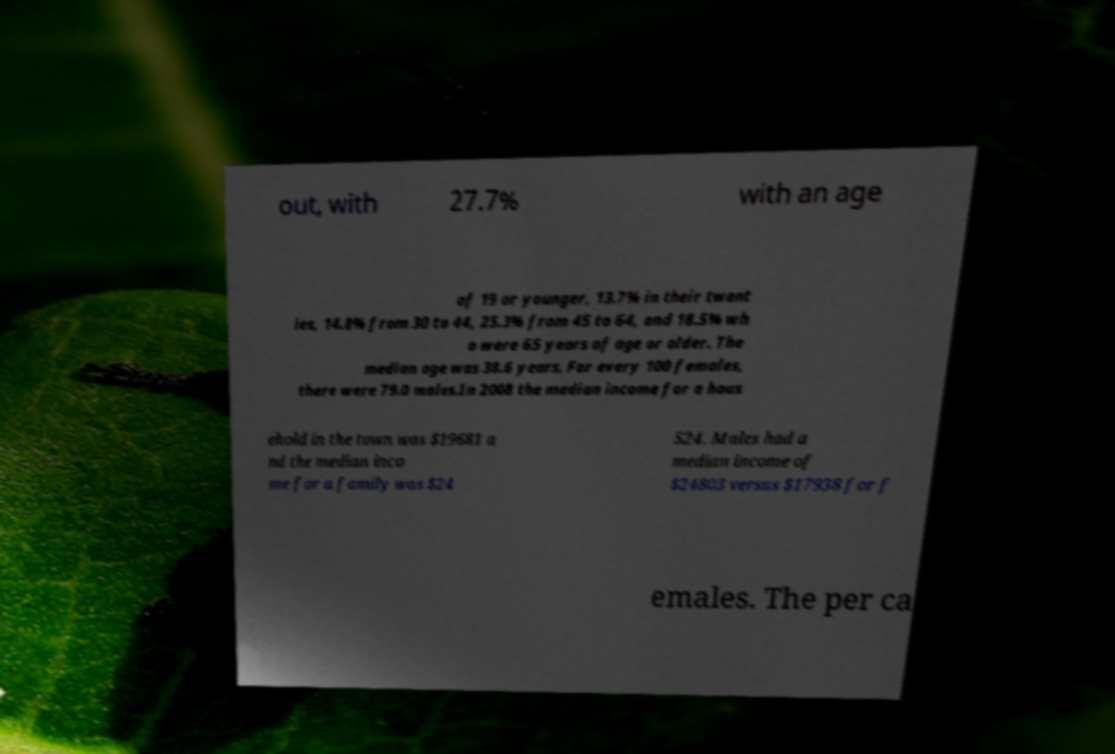Can you accurately transcribe the text from the provided image for me? out, with 27.7% with an age of 19 or younger, 13.7% in their twent ies, 14.8% from 30 to 44, 25.3% from 45 to 64, and 18.5% wh o were 65 years of age or older. The median age was 38.6 years. For every 100 females, there were 79.0 males.In 2008 the median income for a hous ehold in the town was $19681 a nd the median inco me for a family was $24 524. Males had a median income of $24803 versus $17938 for f emales. The per ca 